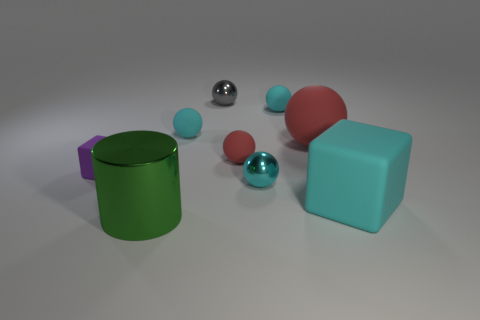Subtract all cyan metal spheres. How many spheres are left? 5 Subtract all purple blocks. How many cyan spheres are left? 3 Subtract all gray spheres. How many spheres are left? 5 Subtract 3 balls. How many balls are left? 3 Subtract all spheres. How many objects are left? 3 Subtract 0 blue cylinders. How many objects are left? 9 Subtract all yellow cylinders. Subtract all blue spheres. How many cylinders are left? 1 Subtract all big purple metallic objects. Subtract all gray metal objects. How many objects are left? 8 Add 2 spheres. How many spheres are left? 8 Add 8 cyan rubber cubes. How many cyan rubber cubes exist? 9 